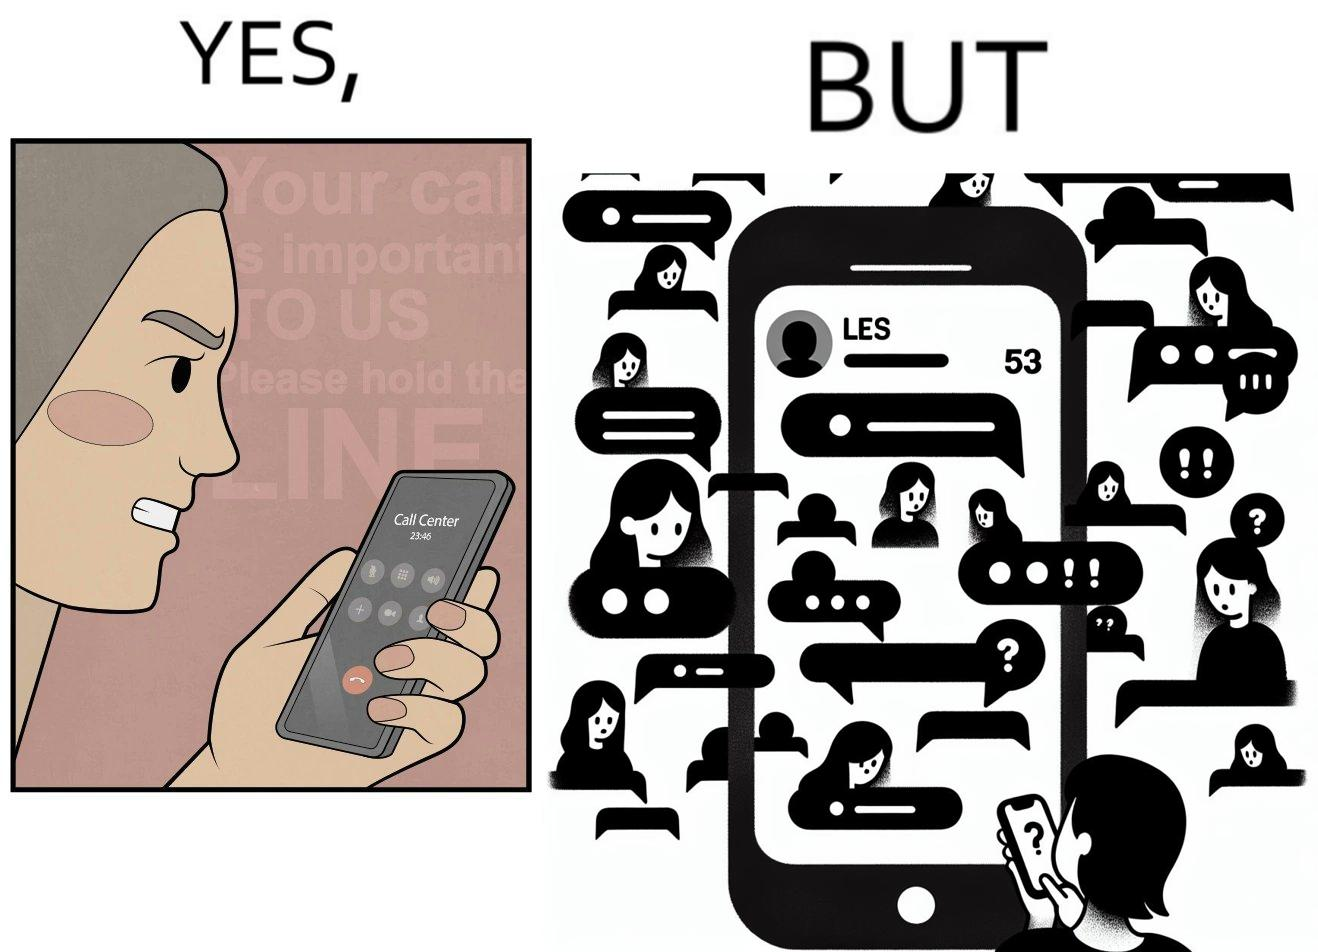What is the satirical meaning behind this image? The image is ironical because while the woman is annoyed by the unresponsiveness of the call center, she herself is being unresponsive to many people in the chat. 